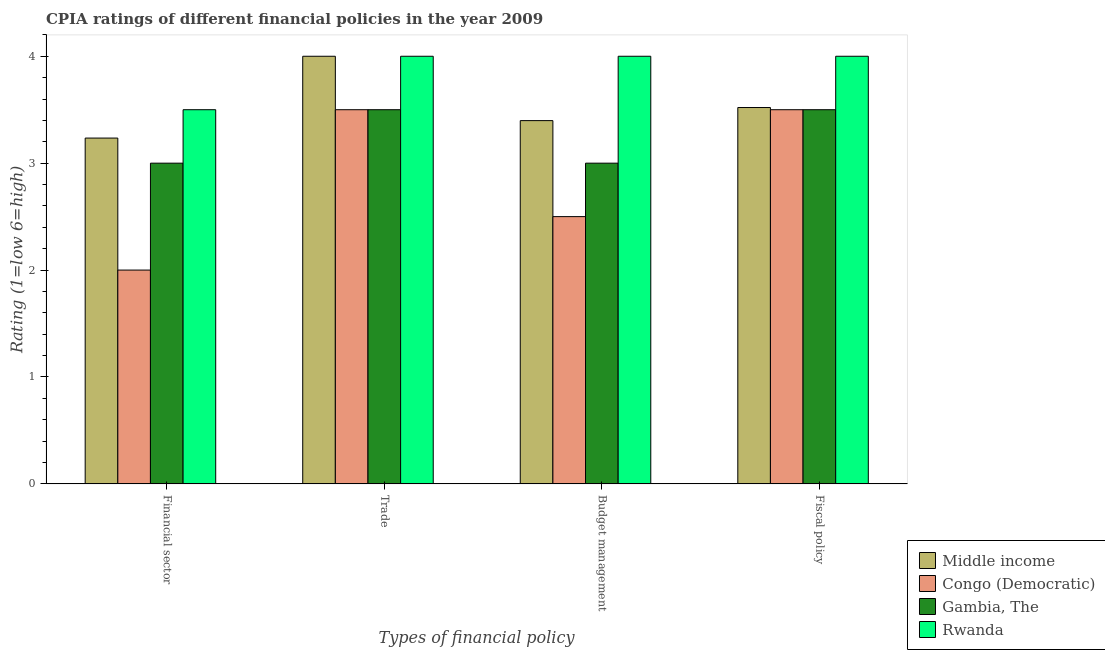How many different coloured bars are there?
Ensure brevity in your answer.  4. Are the number of bars on each tick of the X-axis equal?
Provide a succinct answer. Yes. What is the label of the 2nd group of bars from the left?
Your answer should be very brief. Trade. Across all countries, what is the maximum cpia rating of fiscal policy?
Provide a succinct answer. 4. Across all countries, what is the minimum cpia rating of trade?
Provide a succinct answer. 3.5. In which country was the cpia rating of trade maximum?
Provide a short and direct response. Middle income. In which country was the cpia rating of budget management minimum?
Make the answer very short. Congo (Democratic). What is the total cpia rating of trade in the graph?
Ensure brevity in your answer.  15. What is the difference between the cpia rating of fiscal policy in Middle income and that in Gambia, The?
Provide a short and direct response. 0.02. What is the difference between the cpia rating of trade in Congo (Democratic) and the cpia rating of budget management in Rwanda?
Offer a very short reply. -0.5. What is the average cpia rating of financial sector per country?
Provide a short and direct response. 2.93. What is the difference between the cpia rating of budget management and cpia rating of financial sector in Gambia, The?
Your response must be concise. 0. In how many countries, is the cpia rating of financial sector greater than 0.4 ?
Give a very brief answer. 4. What is the ratio of the cpia rating of fiscal policy in Rwanda to that in Congo (Democratic)?
Ensure brevity in your answer.  1.14. What is the difference between the highest and the second highest cpia rating of budget management?
Keep it short and to the point. 0.6. What does the 3rd bar from the left in Financial sector represents?
Make the answer very short. Gambia, The. What does the 4th bar from the right in Financial sector represents?
Provide a succinct answer. Middle income. Is it the case that in every country, the sum of the cpia rating of financial sector and cpia rating of trade is greater than the cpia rating of budget management?
Your response must be concise. Yes. How many bars are there?
Offer a terse response. 16. Are all the bars in the graph horizontal?
Provide a succinct answer. No. What is the difference between two consecutive major ticks on the Y-axis?
Your answer should be very brief. 1. Are the values on the major ticks of Y-axis written in scientific E-notation?
Provide a succinct answer. No. Does the graph contain any zero values?
Ensure brevity in your answer.  No. What is the title of the graph?
Keep it short and to the point. CPIA ratings of different financial policies in the year 2009. What is the label or title of the X-axis?
Make the answer very short. Types of financial policy. What is the Rating (1=low 6=high) in Middle income in Financial sector?
Provide a short and direct response. 3.23. What is the Rating (1=low 6=high) in Rwanda in Financial sector?
Give a very brief answer. 3.5. What is the Rating (1=low 6=high) in Gambia, The in Trade?
Provide a short and direct response. 3.5. What is the Rating (1=low 6=high) of Rwanda in Trade?
Provide a succinct answer. 4. What is the Rating (1=low 6=high) of Middle income in Budget management?
Your answer should be very brief. 3.4. What is the Rating (1=low 6=high) of Gambia, The in Budget management?
Offer a terse response. 3. What is the Rating (1=low 6=high) in Rwanda in Budget management?
Ensure brevity in your answer.  4. What is the Rating (1=low 6=high) of Middle income in Fiscal policy?
Your response must be concise. 3.52. What is the Rating (1=low 6=high) of Congo (Democratic) in Fiscal policy?
Keep it short and to the point. 3.5. What is the Rating (1=low 6=high) in Rwanda in Fiscal policy?
Ensure brevity in your answer.  4. Across all Types of financial policy, what is the maximum Rating (1=low 6=high) in Rwanda?
Offer a terse response. 4. Across all Types of financial policy, what is the minimum Rating (1=low 6=high) in Middle income?
Give a very brief answer. 3.23. Across all Types of financial policy, what is the minimum Rating (1=low 6=high) of Congo (Democratic)?
Offer a very short reply. 2. Across all Types of financial policy, what is the minimum Rating (1=low 6=high) of Gambia, The?
Your response must be concise. 3. Across all Types of financial policy, what is the minimum Rating (1=low 6=high) in Rwanda?
Your answer should be very brief. 3.5. What is the total Rating (1=low 6=high) in Middle income in the graph?
Your response must be concise. 14.15. What is the difference between the Rating (1=low 6=high) in Middle income in Financial sector and that in Trade?
Your response must be concise. -0.77. What is the difference between the Rating (1=low 6=high) in Congo (Democratic) in Financial sector and that in Trade?
Your response must be concise. -1.5. What is the difference between the Rating (1=low 6=high) of Rwanda in Financial sector and that in Trade?
Your answer should be compact. -0.5. What is the difference between the Rating (1=low 6=high) in Middle income in Financial sector and that in Budget management?
Your answer should be very brief. -0.16. What is the difference between the Rating (1=low 6=high) in Congo (Democratic) in Financial sector and that in Budget management?
Your response must be concise. -0.5. What is the difference between the Rating (1=low 6=high) in Gambia, The in Financial sector and that in Budget management?
Provide a succinct answer. 0. What is the difference between the Rating (1=low 6=high) of Middle income in Financial sector and that in Fiscal policy?
Offer a very short reply. -0.29. What is the difference between the Rating (1=low 6=high) of Congo (Democratic) in Financial sector and that in Fiscal policy?
Your response must be concise. -1.5. What is the difference between the Rating (1=low 6=high) of Middle income in Trade and that in Budget management?
Your answer should be compact. 0.6. What is the difference between the Rating (1=low 6=high) in Rwanda in Trade and that in Budget management?
Give a very brief answer. 0. What is the difference between the Rating (1=low 6=high) in Middle income in Trade and that in Fiscal policy?
Ensure brevity in your answer.  0.48. What is the difference between the Rating (1=low 6=high) in Gambia, The in Trade and that in Fiscal policy?
Give a very brief answer. 0. What is the difference between the Rating (1=low 6=high) in Middle income in Budget management and that in Fiscal policy?
Your response must be concise. -0.12. What is the difference between the Rating (1=low 6=high) in Congo (Democratic) in Budget management and that in Fiscal policy?
Your answer should be very brief. -1. What is the difference between the Rating (1=low 6=high) in Middle income in Financial sector and the Rating (1=low 6=high) in Congo (Democratic) in Trade?
Provide a succinct answer. -0.27. What is the difference between the Rating (1=low 6=high) in Middle income in Financial sector and the Rating (1=low 6=high) in Gambia, The in Trade?
Make the answer very short. -0.27. What is the difference between the Rating (1=low 6=high) of Middle income in Financial sector and the Rating (1=low 6=high) of Rwanda in Trade?
Ensure brevity in your answer.  -0.77. What is the difference between the Rating (1=low 6=high) of Middle income in Financial sector and the Rating (1=low 6=high) of Congo (Democratic) in Budget management?
Your response must be concise. 0.73. What is the difference between the Rating (1=low 6=high) in Middle income in Financial sector and the Rating (1=low 6=high) in Gambia, The in Budget management?
Offer a very short reply. 0.23. What is the difference between the Rating (1=low 6=high) of Middle income in Financial sector and the Rating (1=low 6=high) of Rwanda in Budget management?
Keep it short and to the point. -0.77. What is the difference between the Rating (1=low 6=high) of Gambia, The in Financial sector and the Rating (1=low 6=high) of Rwanda in Budget management?
Ensure brevity in your answer.  -1. What is the difference between the Rating (1=low 6=high) of Middle income in Financial sector and the Rating (1=low 6=high) of Congo (Democratic) in Fiscal policy?
Provide a succinct answer. -0.27. What is the difference between the Rating (1=low 6=high) in Middle income in Financial sector and the Rating (1=low 6=high) in Gambia, The in Fiscal policy?
Make the answer very short. -0.27. What is the difference between the Rating (1=low 6=high) in Middle income in Financial sector and the Rating (1=low 6=high) in Rwanda in Fiscal policy?
Ensure brevity in your answer.  -0.77. What is the difference between the Rating (1=low 6=high) of Gambia, The in Financial sector and the Rating (1=low 6=high) of Rwanda in Fiscal policy?
Provide a succinct answer. -1. What is the difference between the Rating (1=low 6=high) of Middle income in Trade and the Rating (1=low 6=high) of Rwanda in Budget management?
Give a very brief answer. 0. What is the difference between the Rating (1=low 6=high) of Congo (Democratic) in Trade and the Rating (1=low 6=high) of Gambia, The in Budget management?
Offer a terse response. 0.5. What is the difference between the Rating (1=low 6=high) in Congo (Democratic) in Trade and the Rating (1=low 6=high) in Rwanda in Budget management?
Your response must be concise. -0.5. What is the difference between the Rating (1=low 6=high) of Gambia, The in Trade and the Rating (1=low 6=high) of Rwanda in Budget management?
Make the answer very short. -0.5. What is the difference between the Rating (1=low 6=high) in Middle income in Trade and the Rating (1=low 6=high) in Rwanda in Fiscal policy?
Your response must be concise. 0. What is the difference between the Rating (1=low 6=high) of Congo (Democratic) in Trade and the Rating (1=low 6=high) of Gambia, The in Fiscal policy?
Provide a short and direct response. 0. What is the difference between the Rating (1=low 6=high) of Congo (Democratic) in Trade and the Rating (1=low 6=high) of Rwanda in Fiscal policy?
Your answer should be compact. -0.5. What is the difference between the Rating (1=low 6=high) of Middle income in Budget management and the Rating (1=low 6=high) of Congo (Democratic) in Fiscal policy?
Offer a very short reply. -0.1. What is the difference between the Rating (1=low 6=high) in Middle income in Budget management and the Rating (1=low 6=high) in Gambia, The in Fiscal policy?
Your response must be concise. -0.1. What is the difference between the Rating (1=low 6=high) in Middle income in Budget management and the Rating (1=low 6=high) in Rwanda in Fiscal policy?
Your answer should be compact. -0.6. What is the difference between the Rating (1=low 6=high) in Congo (Democratic) in Budget management and the Rating (1=low 6=high) in Gambia, The in Fiscal policy?
Your answer should be very brief. -1. What is the difference between the Rating (1=low 6=high) in Congo (Democratic) in Budget management and the Rating (1=low 6=high) in Rwanda in Fiscal policy?
Your response must be concise. -1.5. What is the difference between the Rating (1=low 6=high) of Gambia, The in Budget management and the Rating (1=low 6=high) of Rwanda in Fiscal policy?
Provide a short and direct response. -1. What is the average Rating (1=low 6=high) of Middle income per Types of financial policy?
Your response must be concise. 3.54. What is the average Rating (1=low 6=high) in Congo (Democratic) per Types of financial policy?
Your response must be concise. 2.88. What is the average Rating (1=low 6=high) of Gambia, The per Types of financial policy?
Provide a short and direct response. 3.25. What is the average Rating (1=low 6=high) in Rwanda per Types of financial policy?
Keep it short and to the point. 3.88. What is the difference between the Rating (1=low 6=high) in Middle income and Rating (1=low 6=high) in Congo (Democratic) in Financial sector?
Offer a very short reply. 1.23. What is the difference between the Rating (1=low 6=high) in Middle income and Rating (1=low 6=high) in Gambia, The in Financial sector?
Give a very brief answer. 0.23. What is the difference between the Rating (1=low 6=high) in Middle income and Rating (1=low 6=high) in Rwanda in Financial sector?
Offer a very short reply. -0.27. What is the difference between the Rating (1=low 6=high) of Congo (Democratic) and Rating (1=low 6=high) of Gambia, The in Financial sector?
Provide a short and direct response. -1. What is the difference between the Rating (1=low 6=high) of Gambia, The and Rating (1=low 6=high) of Rwanda in Financial sector?
Provide a succinct answer. -0.5. What is the difference between the Rating (1=low 6=high) of Middle income and Rating (1=low 6=high) of Congo (Democratic) in Trade?
Offer a terse response. 0.5. What is the difference between the Rating (1=low 6=high) of Middle income and Rating (1=low 6=high) of Gambia, The in Trade?
Provide a short and direct response. 0.5. What is the difference between the Rating (1=low 6=high) in Middle income and Rating (1=low 6=high) in Rwanda in Trade?
Offer a terse response. 0. What is the difference between the Rating (1=low 6=high) of Congo (Democratic) and Rating (1=low 6=high) of Gambia, The in Trade?
Your answer should be compact. 0. What is the difference between the Rating (1=low 6=high) of Middle income and Rating (1=low 6=high) of Congo (Democratic) in Budget management?
Your response must be concise. 0.9. What is the difference between the Rating (1=low 6=high) of Middle income and Rating (1=low 6=high) of Gambia, The in Budget management?
Provide a succinct answer. 0.4. What is the difference between the Rating (1=low 6=high) of Middle income and Rating (1=low 6=high) of Rwanda in Budget management?
Offer a very short reply. -0.6. What is the difference between the Rating (1=low 6=high) in Gambia, The and Rating (1=low 6=high) in Rwanda in Budget management?
Your answer should be compact. -1. What is the difference between the Rating (1=low 6=high) in Middle income and Rating (1=low 6=high) in Congo (Democratic) in Fiscal policy?
Provide a succinct answer. 0.02. What is the difference between the Rating (1=low 6=high) in Middle income and Rating (1=low 6=high) in Gambia, The in Fiscal policy?
Offer a terse response. 0.02. What is the difference between the Rating (1=low 6=high) in Middle income and Rating (1=low 6=high) in Rwanda in Fiscal policy?
Give a very brief answer. -0.48. What is the difference between the Rating (1=low 6=high) in Congo (Democratic) and Rating (1=low 6=high) in Gambia, The in Fiscal policy?
Keep it short and to the point. 0. What is the difference between the Rating (1=low 6=high) of Congo (Democratic) and Rating (1=low 6=high) of Rwanda in Fiscal policy?
Offer a very short reply. -0.5. What is the difference between the Rating (1=low 6=high) in Gambia, The and Rating (1=low 6=high) in Rwanda in Fiscal policy?
Provide a succinct answer. -0.5. What is the ratio of the Rating (1=low 6=high) in Middle income in Financial sector to that in Trade?
Your answer should be very brief. 0.81. What is the ratio of the Rating (1=low 6=high) in Congo (Democratic) in Financial sector to that in Trade?
Ensure brevity in your answer.  0.57. What is the ratio of the Rating (1=low 6=high) of Middle income in Financial sector to that in Budget management?
Your response must be concise. 0.95. What is the ratio of the Rating (1=low 6=high) of Congo (Democratic) in Financial sector to that in Budget management?
Your answer should be compact. 0.8. What is the ratio of the Rating (1=low 6=high) in Gambia, The in Financial sector to that in Budget management?
Your answer should be compact. 1. What is the ratio of the Rating (1=low 6=high) of Middle income in Financial sector to that in Fiscal policy?
Ensure brevity in your answer.  0.92. What is the ratio of the Rating (1=low 6=high) in Congo (Democratic) in Financial sector to that in Fiscal policy?
Your answer should be very brief. 0.57. What is the ratio of the Rating (1=low 6=high) of Gambia, The in Financial sector to that in Fiscal policy?
Offer a terse response. 0.86. What is the ratio of the Rating (1=low 6=high) of Middle income in Trade to that in Budget management?
Offer a terse response. 1.18. What is the ratio of the Rating (1=low 6=high) in Congo (Democratic) in Trade to that in Budget management?
Offer a terse response. 1.4. What is the ratio of the Rating (1=low 6=high) in Middle income in Trade to that in Fiscal policy?
Give a very brief answer. 1.14. What is the ratio of the Rating (1=low 6=high) in Congo (Democratic) in Trade to that in Fiscal policy?
Your response must be concise. 1. What is the ratio of the Rating (1=low 6=high) of Middle income in Budget management to that in Fiscal policy?
Offer a very short reply. 0.97. What is the ratio of the Rating (1=low 6=high) of Congo (Democratic) in Budget management to that in Fiscal policy?
Your answer should be very brief. 0.71. What is the difference between the highest and the second highest Rating (1=low 6=high) of Middle income?
Keep it short and to the point. 0.48. What is the difference between the highest and the second highest Rating (1=low 6=high) of Gambia, The?
Keep it short and to the point. 0. What is the difference between the highest and the second highest Rating (1=low 6=high) in Rwanda?
Ensure brevity in your answer.  0. What is the difference between the highest and the lowest Rating (1=low 6=high) of Middle income?
Give a very brief answer. 0.77. What is the difference between the highest and the lowest Rating (1=low 6=high) in Congo (Democratic)?
Your answer should be compact. 1.5. 